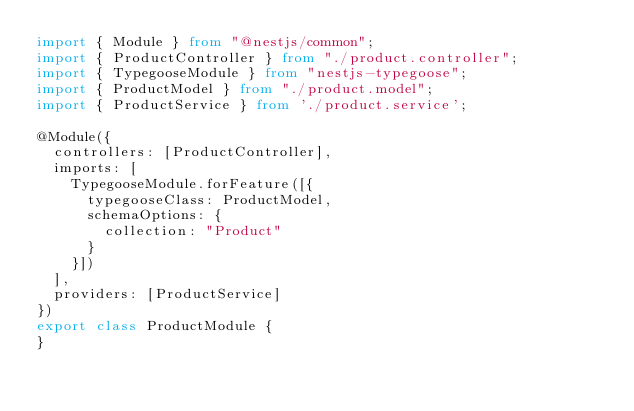<code> <loc_0><loc_0><loc_500><loc_500><_TypeScript_>import { Module } from "@nestjs/common";
import { ProductController } from "./product.controller";
import { TypegooseModule } from "nestjs-typegoose";
import { ProductModel } from "./product.model";
import { ProductService } from './product.service';

@Module({
  controllers: [ProductController],
  imports: [
    TypegooseModule.forFeature([{
      typegooseClass: ProductModel,
      schemaOptions: {
        collection: "Product"
      }
    }])
  ],
  providers: [ProductService]
})
export class ProductModule {
}
</code> 